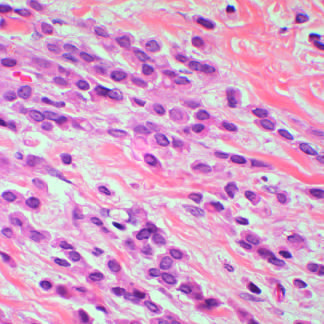re lobular carcinomas composed of noncohesive tumor cells that invade as linear cords of cells and induce little stromal response?
Answer the question using a single word or phrase. Yes 